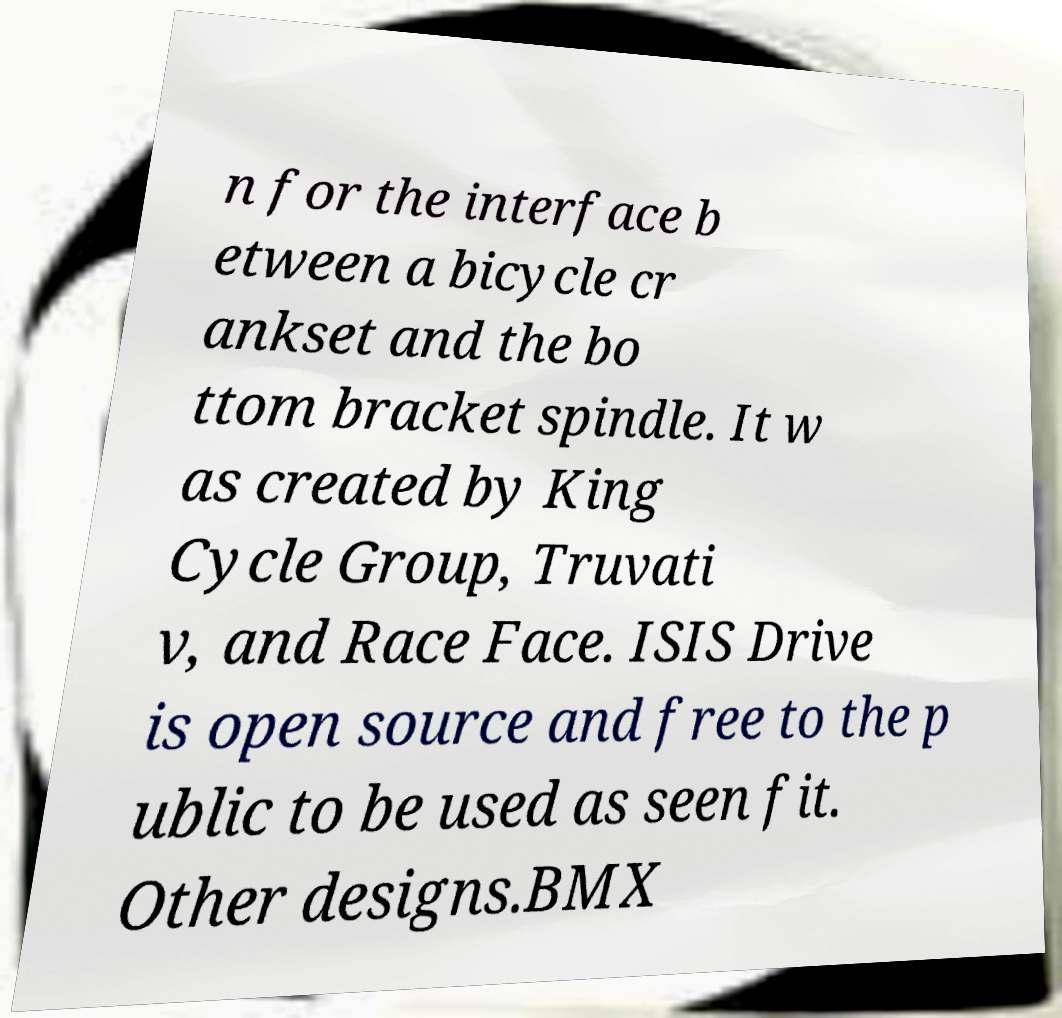Please identify and transcribe the text found in this image. n for the interface b etween a bicycle cr ankset and the bo ttom bracket spindle. It w as created by King Cycle Group, Truvati v, and Race Face. ISIS Drive is open source and free to the p ublic to be used as seen fit. Other designs.BMX 